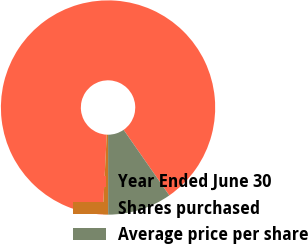<chart> <loc_0><loc_0><loc_500><loc_500><pie_chart><fcel>Year Ended June 30<fcel>Shares purchased<fcel>Average price per share<nl><fcel>89.53%<fcel>0.8%<fcel>9.67%<nl></chart> 